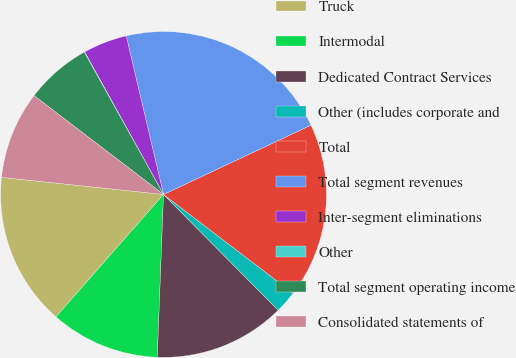Convert chart. <chart><loc_0><loc_0><loc_500><loc_500><pie_chart><fcel>Truck<fcel>Intermodal<fcel>Dedicated Contract Services<fcel>Other (includes corporate and<fcel>Total<fcel>Total segment revenues<fcel>Inter-segment eliminations<fcel>Other<fcel>Total segment operating income<fcel>Consolidated statements of<nl><fcel>15.2%<fcel>10.87%<fcel>13.03%<fcel>2.21%<fcel>17.36%<fcel>21.69%<fcel>4.37%<fcel>0.04%<fcel>6.54%<fcel>8.7%<nl></chart> 